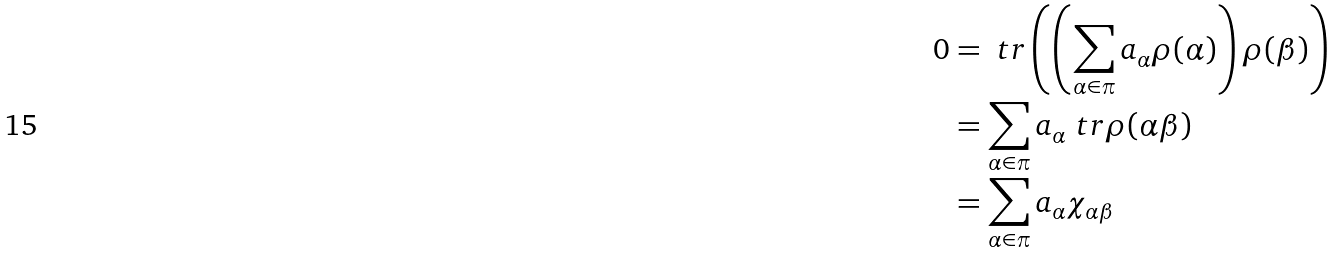<formula> <loc_0><loc_0><loc_500><loc_500>0 & = \ t r \left ( \left ( \sum _ { \alpha \in \pi } a _ { \alpha } \rho ( \alpha ) \right ) \rho ( \beta ) \right ) \\ & = \sum _ { \alpha \in \pi } a _ { \alpha } \ t r \rho ( \alpha \beta ) \\ & = \sum _ { \alpha \in \pi } a _ { \alpha } \chi _ { \alpha \beta }</formula> 